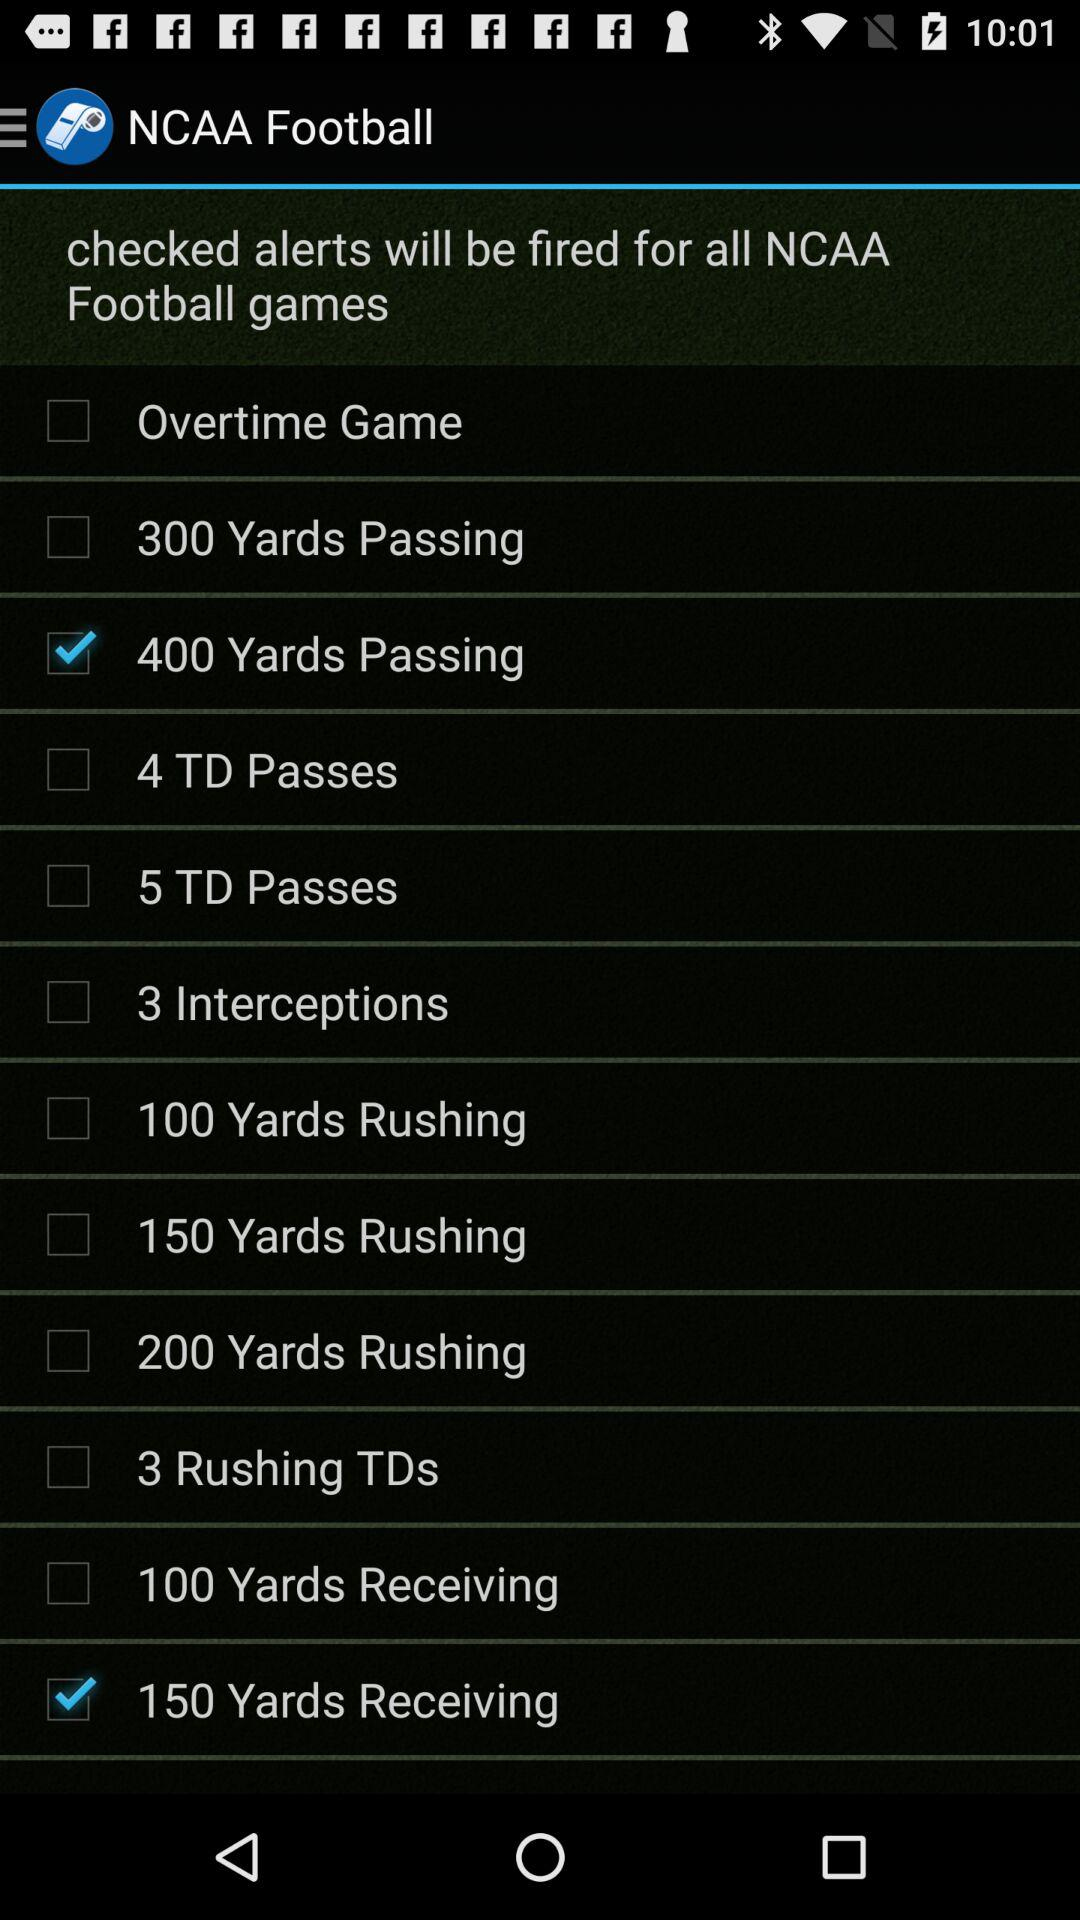For which NCAA football games alerts will be fired? The alerts are "400 Yards Passing" and "150 Yards Receiving". 